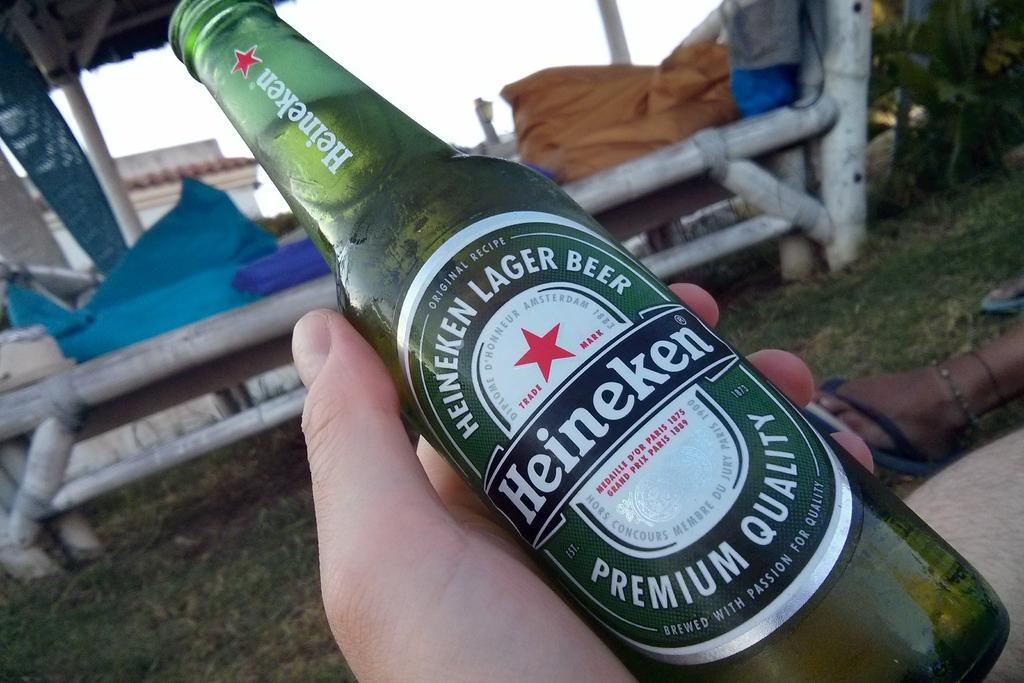What is happening in the image involving a person? The person in the image is catching a bottle with his hands. What can be seen on the bottle being caught? There is a label with text on the bottle. What type of environment is visible in the image? There is grass and a building in the image, suggesting an outdoor setting. What is the condition of the sky in the image? The sky is clear in the image. What type of liquid is being poured by the person's uncle in the image? There is no uncle present in the image, and no liquid is being poured. Is the person wearing a cast on their arm in the image? There is no cast visible on the person's arm in the image. 